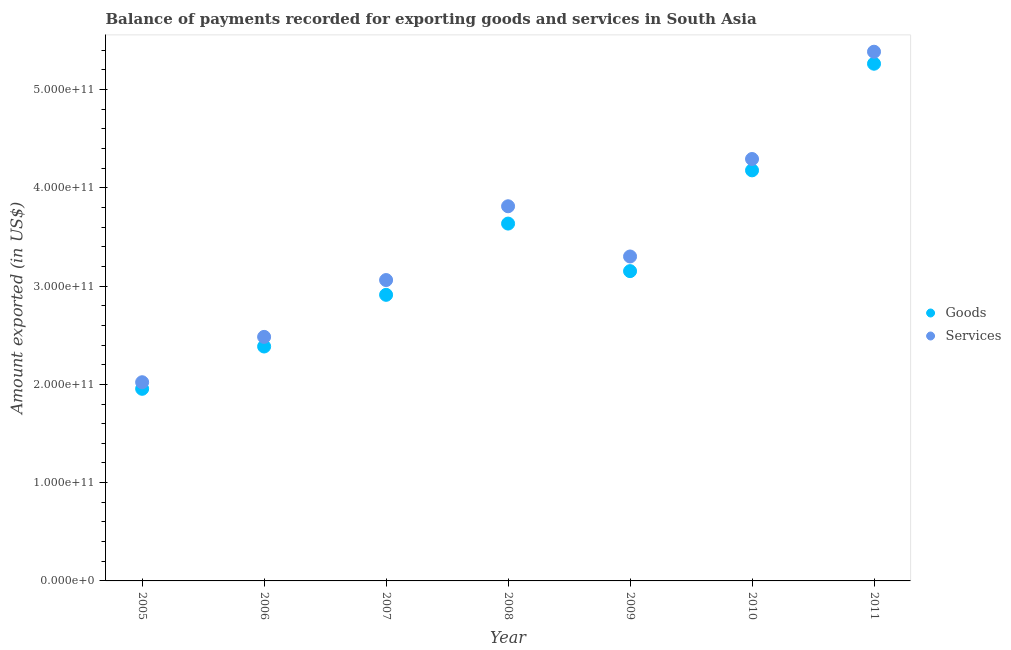Is the number of dotlines equal to the number of legend labels?
Provide a succinct answer. Yes. What is the amount of goods exported in 2007?
Your answer should be compact. 2.91e+11. Across all years, what is the maximum amount of services exported?
Offer a terse response. 5.38e+11. Across all years, what is the minimum amount of goods exported?
Make the answer very short. 1.95e+11. In which year was the amount of goods exported maximum?
Your response must be concise. 2011. What is the total amount of goods exported in the graph?
Keep it short and to the point. 2.35e+12. What is the difference between the amount of services exported in 2007 and that in 2010?
Your answer should be compact. -1.23e+11. What is the difference between the amount of services exported in 2010 and the amount of goods exported in 2006?
Offer a very short reply. 1.91e+11. What is the average amount of goods exported per year?
Your answer should be very brief. 3.35e+11. In the year 2005, what is the difference between the amount of goods exported and amount of services exported?
Provide a succinct answer. -6.70e+09. In how many years, is the amount of goods exported greater than 140000000000 US$?
Make the answer very short. 7. What is the ratio of the amount of services exported in 2008 to that in 2010?
Provide a succinct answer. 0.89. Is the difference between the amount of services exported in 2007 and 2010 greater than the difference between the amount of goods exported in 2007 and 2010?
Provide a short and direct response. Yes. What is the difference between the highest and the second highest amount of services exported?
Your answer should be compact. 1.09e+11. What is the difference between the highest and the lowest amount of services exported?
Your answer should be compact. 3.36e+11. In how many years, is the amount of services exported greater than the average amount of services exported taken over all years?
Offer a very short reply. 3. Is the sum of the amount of services exported in 2007 and 2009 greater than the maximum amount of goods exported across all years?
Your answer should be compact. Yes. Is the amount of goods exported strictly greater than the amount of services exported over the years?
Make the answer very short. No. How many years are there in the graph?
Your answer should be very brief. 7. What is the difference between two consecutive major ticks on the Y-axis?
Ensure brevity in your answer.  1.00e+11. Does the graph contain grids?
Make the answer very short. No. Where does the legend appear in the graph?
Give a very brief answer. Center right. How many legend labels are there?
Make the answer very short. 2. What is the title of the graph?
Your answer should be very brief. Balance of payments recorded for exporting goods and services in South Asia. What is the label or title of the Y-axis?
Ensure brevity in your answer.  Amount exported (in US$). What is the Amount exported (in US$) of Goods in 2005?
Your answer should be compact. 1.95e+11. What is the Amount exported (in US$) of Services in 2005?
Your response must be concise. 2.02e+11. What is the Amount exported (in US$) of Goods in 2006?
Give a very brief answer. 2.39e+11. What is the Amount exported (in US$) of Services in 2006?
Your answer should be very brief. 2.48e+11. What is the Amount exported (in US$) in Goods in 2007?
Provide a short and direct response. 2.91e+11. What is the Amount exported (in US$) of Services in 2007?
Offer a terse response. 3.06e+11. What is the Amount exported (in US$) of Goods in 2008?
Ensure brevity in your answer.  3.64e+11. What is the Amount exported (in US$) of Services in 2008?
Provide a short and direct response. 3.81e+11. What is the Amount exported (in US$) of Goods in 2009?
Give a very brief answer. 3.15e+11. What is the Amount exported (in US$) in Services in 2009?
Keep it short and to the point. 3.30e+11. What is the Amount exported (in US$) in Goods in 2010?
Provide a succinct answer. 4.18e+11. What is the Amount exported (in US$) in Services in 2010?
Give a very brief answer. 4.29e+11. What is the Amount exported (in US$) of Goods in 2011?
Provide a short and direct response. 5.26e+11. What is the Amount exported (in US$) of Services in 2011?
Offer a very short reply. 5.38e+11. Across all years, what is the maximum Amount exported (in US$) in Goods?
Your response must be concise. 5.26e+11. Across all years, what is the maximum Amount exported (in US$) of Services?
Your response must be concise. 5.38e+11. Across all years, what is the minimum Amount exported (in US$) of Goods?
Provide a short and direct response. 1.95e+11. Across all years, what is the minimum Amount exported (in US$) in Services?
Offer a very short reply. 2.02e+11. What is the total Amount exported (in US$) in Goods in the graph?
Your answer should be compact. 2.35e+12. What is the total Amount exported (in US$) in Services in the graph?
Your answer should be very brief. 2.44e+12. What is the difference between the Amount exported (in US$) in Goods in 2005 and that in 2006?
Your answer should be compact. -4.30e+1. What is the difference between the Amount exported (in US$) of Services in 2005 and that in 2006?
Give a very brief answer. -4.61e+1. What is the difference between the Amount exported (in US$) of Goods in 2005 and that in 2007?
Your answer should be compact. -9.56e+1. What is the difference between the Amount exported (in US$) in Services in 2005 and that in 2007?
Offer a terse response. -1.04e+11. What is the difference between the Amount exported (in US$) of Goods in 2005 and that in 2008?
Offer a very short reply. -1.68e+11. What is the difference between the Amount exported (in US$) of Services in 2005 and that in 2008?
Your answer should be compact. -1.79e+11. What is the difference between the Amount exported (in US$) in Goods in 2005 and that in 2009?
Your response must be concise. -1.20e+11. What is the difference between the Amount exported (in US$) of Services in 2005 and that in 2009?
Offer a terse response. -1.28e+11. What is the difference between the Amount exported (in US$) in Goods in 2005 and that in 2010?
Your answer should be very brief. -2.22e+11. What is the difference between the Amount exported (in US$) of Services in 2005 and that in 2010?
Keep it short and to the point. -2.27e+11. What is the difference between the Amount exported (in US$) in Goods in 2005 and that in 2011?
Your answer should be compact. -3.31e+11. What is the difference between the Amount exported (in US$) of Services in 2005 and that in 2011?
Give a very brief answer. -3.36e+11. What is the difference between the Amount exported (in US$) in Goods in 2006 and that in 2007?
Give a very brief answer. -5.26e+1. What is the difference between the Amount exported (in US$) in Services in 2006 and that in 2007?
Offer a very short reply. -5.78e+1. What is the difference between the Amount exported (in US$) in Goods in 2006 and that in 2008?
Your answer should be very brief. -1.25e+11. What is the difference between the Amount exported (in US$) in Services in 2006 and that in 2008?
Make the answer very short. -1.33e+11. What is the difference between the Amount exported (in US$) of Goods in 2006 and that in 2009?
Offer a terse response. -7.67e+1. What is the difference between the Amount exported (in US$) of Services in 2006 and that in 2009?
Offer a terse response. -8.18e+1. What is the difference between the Amount exported (in US$) of Goods in 2006 and that in 2010?
Make the answer very short. -1.79e+11. What is the difference between the Amount exported (in US$) of Services in 2006 and that in 2010?
Ensure brevity in your answer.  -1.81e+11. What is the difference between the Amount exported (in US$) of Goods in 2006 and that in 2011?
Make the answer very short. -2.88e+11. What is the difference between the Amount exported (in US$) in Services in 2006 and that in 2011?
Make the answer very short. -2.90e+11. What is the difference between the Amount exported (in US$) of Goods in 2007 and that in 2008?
Keep it short and to the point. -7.25e+1. What is the difference between the Amount exported (in US$) in Services in 2007 and that in 2008?
Your response must be concise. -7.51e+1. What is the difference between the Amount exported (in US$) of Goods in 2007 and that in 2009?
Your response must be concise. -2.41e+1. What is the difference between the Amount exported (in US$) in Services in 2007 and that in 2009?
Give a very brief answer. -2.40e+1. What is the difference between the Amount exported (in US$) in Goods in 2007 and that in 2010?
Offer a terse response. -1.27e+11. What is the difference between the Amount exported (in US$) in Services in 2007 and that in 2010?
Give a very brief answer. -1.23e+11. What is the difference between the Amount exported (in US$) of Goods in 2007 and that in 2011?
Your answer should be compact. -2.35e+11. What is the difference between the Amount exported (in US$) in Services in 2007 and that in 2011?
Keep it short and to the point. -2.32e+11. What is the difference between the Amount exported (in US$) in Goods in 2008 and that in 2009?
Offer a very short reply. 4.84e+1. What is the difference between the Amount exported (in US$) in Services in 2008 and that in 2009?
Provide a succinct answer. 5.11e+1. What is the difference between the Amount exported (in US$) of Goods in 2008 and that in 2010?
Your response must be concise. -5.42e+1. What is the difference between the Amount exported (in US$) in Services in 2008 and that in 2010?
Your response must be concise. -4.81e+1. What is the difference between the Amount exported (in US$) in Goods in 2008 and that in 2011?
Make the answer very short. -1.63e+11. What is the difference between the Amount exported (in US$) of Services in 2008 and that in 2011?
Your answer should be compact. -1.57e+11. What is the difference between the Amount exported (in US$) in Goods in 2009 and that in 2010?
Make the answer very short. -1.03e+11. What is the difference between the Amount exported (in US$) in Services in 2009 and that in 2010?
Your answer should be compact. -9.92e+1. What is the difference between the Amount exported (in US$) in Goods in 2009 and that in 2011?
Your answer should be very brief. -2.11e+11. What is the difference between the Amount exported (in US$) of Services in 2009 and that in 2011?
Make the answer very short. -2.08e+11. What is the difference between the Amount exported (in US$) in Goods in 2010 and that in 2011?
Ensure brevity in your answer.  -1.08e+11. What is the difference between the Amount exported (in US$) of Services in 2010 and that in 2011?
Provide a succinct answer. -1.09e+11. What is the difference between the Amount exported (in US$) of Goods in 2005 and the Amount exported (in US$) of Services in 2006?
Keep it short and to the point. -5.28e+1. What is the difference between the Amount exported (in US$) of Goods in 2005 and the Amount exported (in US$) of Services in 2007?
Offer a very short reply. -1.11e+11. What is the difference between the Amount exported (in US$) of Goods in 2005 and the Amount exported (in US$) of Services in 2008?
Your response must be concise. -1.86e+11. What is the difference between the Amount exported (in US$) of Goods in 2005 and the Amount exported (in US$) of Services in 2009?
Give a very brief answer. -1.35e+11. What is the difference between the Amount exported (in US$) of Goods in 2005 and the Amount exported (in US$) of Services in 2010?
Offer a terse response. -2.34e+11. What is the difference between the Amount exported (in US$) in Goods in 2005 and the Amount exported (in US$) in Services in 2011?
Provide a short and direct response. -3.43e+11. What is the difference between the Amount exported (in US$) in Goods in 2006 and the Amount exported (in US$) in Services in 2007?
Provide a short and direct response. -6.76e+1. What is the difference between the Amount exported (in US$) in Goods in 2006 and the Amount exported (in US$) in Services in 2008?
Provide a succinct answer. -1.43e+11. What is the difference between the Amount exported (in US$) of Goods in 2006 and the Amount exported (in US$) of Services in 2009?
Provide a succinct answer. -9.16e+1. What is the difference between the Amount exported (in US$) in Goods in 2006 and the Amount exported (in US$) in Services in 2010?
Your answer should be compact. -1.91e+11. What is the difference between the Amount exported (in US$) of Goods in 2006 and the Amount exported (in US$) of Services in 2011?
Ensure brevity in your answer.  -3.00e+11. What is the difference between the Amount exported (in US$) of Goods in 2007 and the Amount exported (in US$) of Services in 2008?
Your answer should be very brief. -9.01e+1. What is the difference between the Amount exported (in US$) in Goods in 2007 and the Amount exported (in US$) in Services in 2009?
Your answer should be compact. -3.90e+1. What is the difference between the Amount exported (in US$) of Goods in 2007 and the Amount exported (in US$) of Services in 2010?
Your answer should be compact. -1.38e+11. What is the difference between the Amount exported (in US$) in Goods in 2007 and the Amount exported (in US$) in Services in 2011?
Make the answer very short. -2.47e+11. What is the difference between the Amount exported (in US$) of Goods in 2008 and the Amount exported (in US$) of Services in 2009?
Provide a short and direct response. 3.35e+1. What is the difference between the Amount exported (in US$) in Goods in 2008 and the Amount exported (in US$) in Services in 2010?
Provide a succinct answer. -6.57e+1. What is the difference between the Amount exported (in US$) of Goods in 2008 and the Amount exported (in US$) of Services in 2011?
Provide a succinct answer. -1.75e+11. What is the difference between the Amount exported (in US$) of Goods in 2009 and the Amount exported (in US$) of Services in 2010?
Provide a succinct answer. -1.14e+11. What is the difference between the Amount exported (in US$) in Goods in 2009 and the Amount exported (in US$) in Services in 2011?
Provide a short and direct response. -2.23e+11. What is the difference between the Amount exported (in US$) in Goods in 2010 and the Amount exported (in US$) in Services in 2011?
Your answer should be compact. -1.21e+11. What is the average Amount exported (in US$) in Goods per year?
Give a very brief answer. 3.35e+11. What is the average Amount exported (in US$) of Services per year?
Ensure brevity in your answer.  3.48e+11. In the year 2005, what is the difference between the Amount exported (in US$) of Goods and Amount exported (in US$) of Services?
Your answer should be compact. -6.70e+09. In the year 2006, what is the difference between the Amount exported (in US$) in Goods and Amount exported (in US$) in Services?
Offer a very short reply. -9.78e+09. In the year 2007, what is the difference between the Amount exported (in US$) in Goods and Amount exported (in US$) in Services?
Make the answer very short. -1.50e+1. In the year 2008, what is the difference between the Amount exported (in US$) in Goods and Amount exported (in US$) in Services?
Provide a short and direct response. -1.76e+1. In the year 2009, what is the difference between the Amount exported (in US$) in Goods and Amount exported (in US$) in Services?
Offer a very short reply. -1.49e+1. In the year 2010, what is the difference between the Amount exported (in US$) of Goods and Amount exported (in US$) of Services?
Give a very brief answer. -1.15e+1. In the year 2011, what is the difference between the Amount exported (in US$) in Goods and Amount exported (in US$) in Services?
Give a very brief answer. -1.22e+1. What is the ratio of the Amount exported (in US$) of Goods in 2005 to that in 2006?
Your answer should be compact. 0.82. What is the ratio of the Amount exported (in US$) in Services in 2005 to that in 2006?
Provide a succinct answer. 0.81. What is the ratio of the Amount exported (in US$) of Goods in 2005 to that in 2007?
Provide a short and direct response. 0.67. What is the ratio of the Amount exported (in US$) in Services in 2005 to that in 2007?
Provide a succinct answer. 0.66. What is the ratio of the Amount exported (in US$) in Goods in 2005 to that in 2008?
Your answer should be compact. 0.54. What is the ratio of the Amount exported (in US$) of Services in 2005 to that in 2008?
Offer a very short reply. 0.53. What is the ratio of the Amount exported (in US$) of Goods in 2005 to that in 2009?
Your answer should be very brief. 0.62. What is the ratio of the Amount exported (in US$) in Services in 2005 to that in 2009?
Make the answer very short. 0.61. What is the ratio of the Amount exported (in US$) of Goods in 2005 to that in 2010?
Ensure brevity in your answer.  0.47. What is the ratio of the Amount exported (in US$) in Services in 2005 to that in 2010?
Your response must be concise. 0.47. What is the ratio of the Amount exported (in US$) of Goods in 2005 to that in 2011?
Provide a short and direct response. 0.37. What is the ratio of the Amount exported (in US$) of Services in 2005 to that in 2011?
Provide a succinct answer. 0.38. What is the ratio of the Amount exported (in US$) of Goods in 2006 to that in 2007?
Your response must be concise. 0.82. What is the ratio of the Amount exported (in US$) in Services in 2006 to that in 2007?
Your response must be concise. 0.81. What is the ratio of the Amount exported (in US$) in Goods in 2006 to that in 2008?
Give a very brief answer. 0.66. What is the ratio of the Amount exported (in US$) in Services in 2006 to that in 2008?
Give a very brief answer. 0.65. What is the ratio of the Amount exported (in US$) of Goods in 2006 to that in 2009?
Give a very brief answer. 0.76. What is the ratio of the Amount exported (in US$) of Services in 2006 to that in 2009?
Ensure brevity in your answer.  0.75. What is the ratio of the Amount exported (in US$) in Goods in 2006 to that in 2010?
Offer a very short reply. 0.57. What is the ratio of the Amount exported (in US$) in Services in 2006 to that in 2010?
Offer a very short reply. 0.58. What is the ratio of the Amount exported (in US$) in Goods in 2006 to that in 2011?
Provide a succinct answer. 0.45. What is the ratio of the Amount exported (in US$) in Services in 2006 to that in 2011?
Provide a short and direct response. 0.46. What is the ratio of the Amount exported (in US$) in Goods in 2007 to that in 2008?
Your answer should be compact. 0.8. What is the ratio of the Amount exported (in US$) in Services in 2007 to that in 2008?
Your answer should be compact. 0.8. What is the ratio of the Amount exported (in US$) of Goods in 2007 to that in 2009?
Give a very brief answer. 0.92. What is the ratio of the Amount exported (in US$) in Services in 2007 to that in 2009?
Keep it short and to the point. 0.93. What is the ratio of the Amount exported (in US$) in Goods in 2007 to that in 2010?
Give a very brief answer. 0.7. What is the ratio of the Amount exported (in US$) in Services in 2007 to that in 2010?
Ensure brevity in your answer.  0.71. What is the ratio of the Amount exported (in US$) of Goods in 2007 to that in 2011?
Your answer should be very brief. 0.55. What is the ratio of the Amount exported (in US$) of Services in 2007 to that in 2011?
Your answer should be compact. 0.57. What is the ratio of the Amount exported (in US$) in Goods in 2008 to that in 2009?
Offer a terse response. 1.15. What is the ratio of the Amount exported (in US$) in Services in 2008 to that in 2009?
Provide a succinct answer. 1.15. What is the ratio of the Amount exported (in US$) in Goods in 2008 to that in 2010?
Offer a very short reply. 0.87. What is the ratio of the Amount exported (in US$) of Services in 2008 to that in 2010?
Provide a succinct answer. 0.89. What is the ratio of the Amount exported (in US$) in Goods in 2008 to that in 2011?
Provide a succinct answer. 0.69. What is the ratio of the Amount exported (in US$) in Services in 2008 to that in 2011?
Provide a succinct answer. 0.71. What is the ratio of the Amount exported (in US$) of Goods in 2009 to that in 2010?
Keep it short and to the point. 0.75. What is the ratio of the Amount exported (in US$) of Services in 2009 to that in 2010?
Ensure brevity in your answer.  0.77. What is the ratio of the Amount exported (in US$) in Goods in 2009 to that in 2011?
Provide a succinct answer. 0.6. What is the ratio of the Amount exported (in US$) in Services in 2009 to that in 2011?
Provide a succinct answer. 0.61. What is the ratio of the Amount exported (in US$) in Goods in 2010 to that in 2011?
Your answer should be very brief. 0.79. What is the ratio of the Amount exported (in US$) of Services in 2010 to that in 2011?
Keep it short and to the point. 0.8. What is the difference between the highest and the second highest Amount exported (in US$) of Goods?
Your answer should be very brief. 1.08e+11. What is the difference between the highest and the second highest Amount exported (in US$) in Services?
Your answer should be compact. 1.09e+11. What is the difference between the highest and the lowest Amount exported (in US$) in Goods?
Your response must be concise. 3.31e+11. What is the difference between the highest and the lowest Amount exported (in US$) in Services?
Offer a terse response. 3.36e+11. 